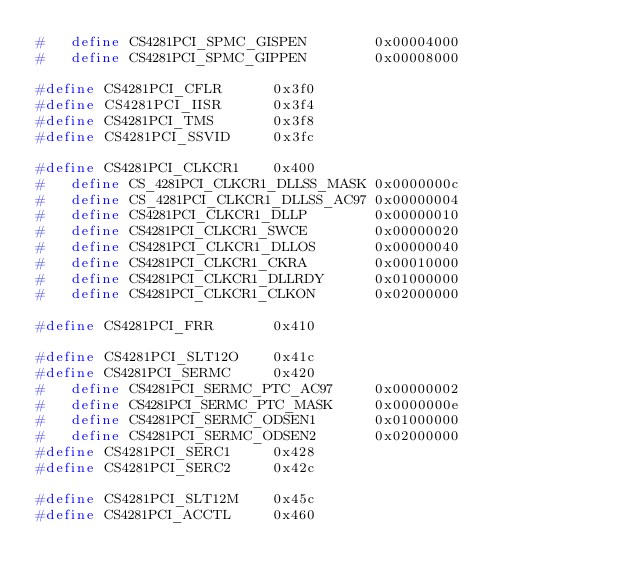Convert code to text. <code><loc_0><loc_0><loc_500><loc_500><_C_>#	define CS4281PCI_SPMC_GISPEN		0x00004000
#	define CS4281PCI_SPMC_GIPPEN		0x00008000

#define CS4281PCI_CFLR		0x3f0
#define CS4281PCI_IISR		0x3f4
#define CS4281PCI_TMS		0x3f8
#define CS4281PCI_SSVID		0x3fc

#define CS4281PCI_CLKCR1	0x400
#	define CS_4281PCI_CLKCR1_DLLSS_MASK	0x0000000c
#	define CS_4281PCI_CLKCR1_DLLSS_AC97	0x00000004
#	define CS4281PCI_CLKCR1_DLLP		0x00000010
#	define CS4281PCI_CLKCR1_SWCE		0x00000020
#	define CS4281PCI_CLKCR1_DLLOS		0x00000040
#	define CS4281PCI_CLKCR1_CKRA		0x00010000
#	define CS4281PCI_CLKCR1_DLLRDY		0x01000000
#	define CS4281PCI_CLKCR1_CLKON		0x02000000

#define CS4281PCI_FRR		0x410

#define CS4281PCI_SLT12O	0x41c
#define CS4281PCI_SERMC		0x420
#	define CS4281PCI_SERMC_PTC_AC97		0x00000002
#	define CS4281PCI_SERMC_PTC_MASK		0x0000000e
#	define CS4281PCI_SERMC_ODSEN1		0x01000000
#	define CS4281PCI_SERMC_ODSEN2		0x02000000
#define CS4281PCI_SERC1		0x428
#define CS4281PCI_SERC2		0x42c

#define CS4281PCI_SLT12M	0x45c
#define CS4281PCI_ACCTL		0x460</code> 